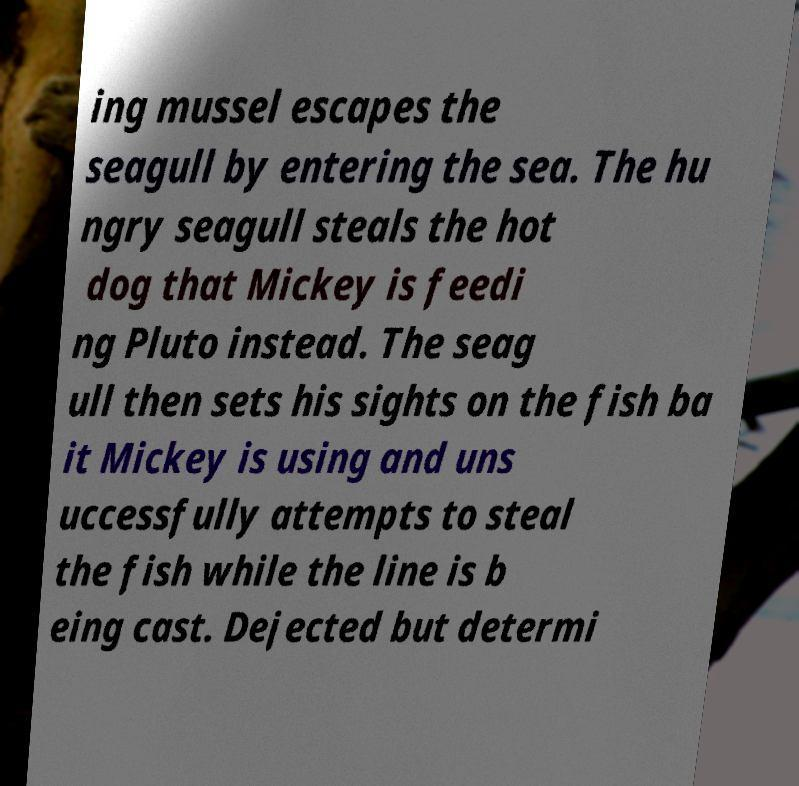What messages or text are displayed in this image? I need them in a readable, typed format. ing mussel escapes the seagull by entering the sea. The hu ngry seagull steals the hot dog that Mickey is feedi ng Pluto instead. The seag ull then sets his sights on the fish ba it Mickey is using and uns uccessfully attempts to steal the fish while the line is b eing cast. Dejected but determi 